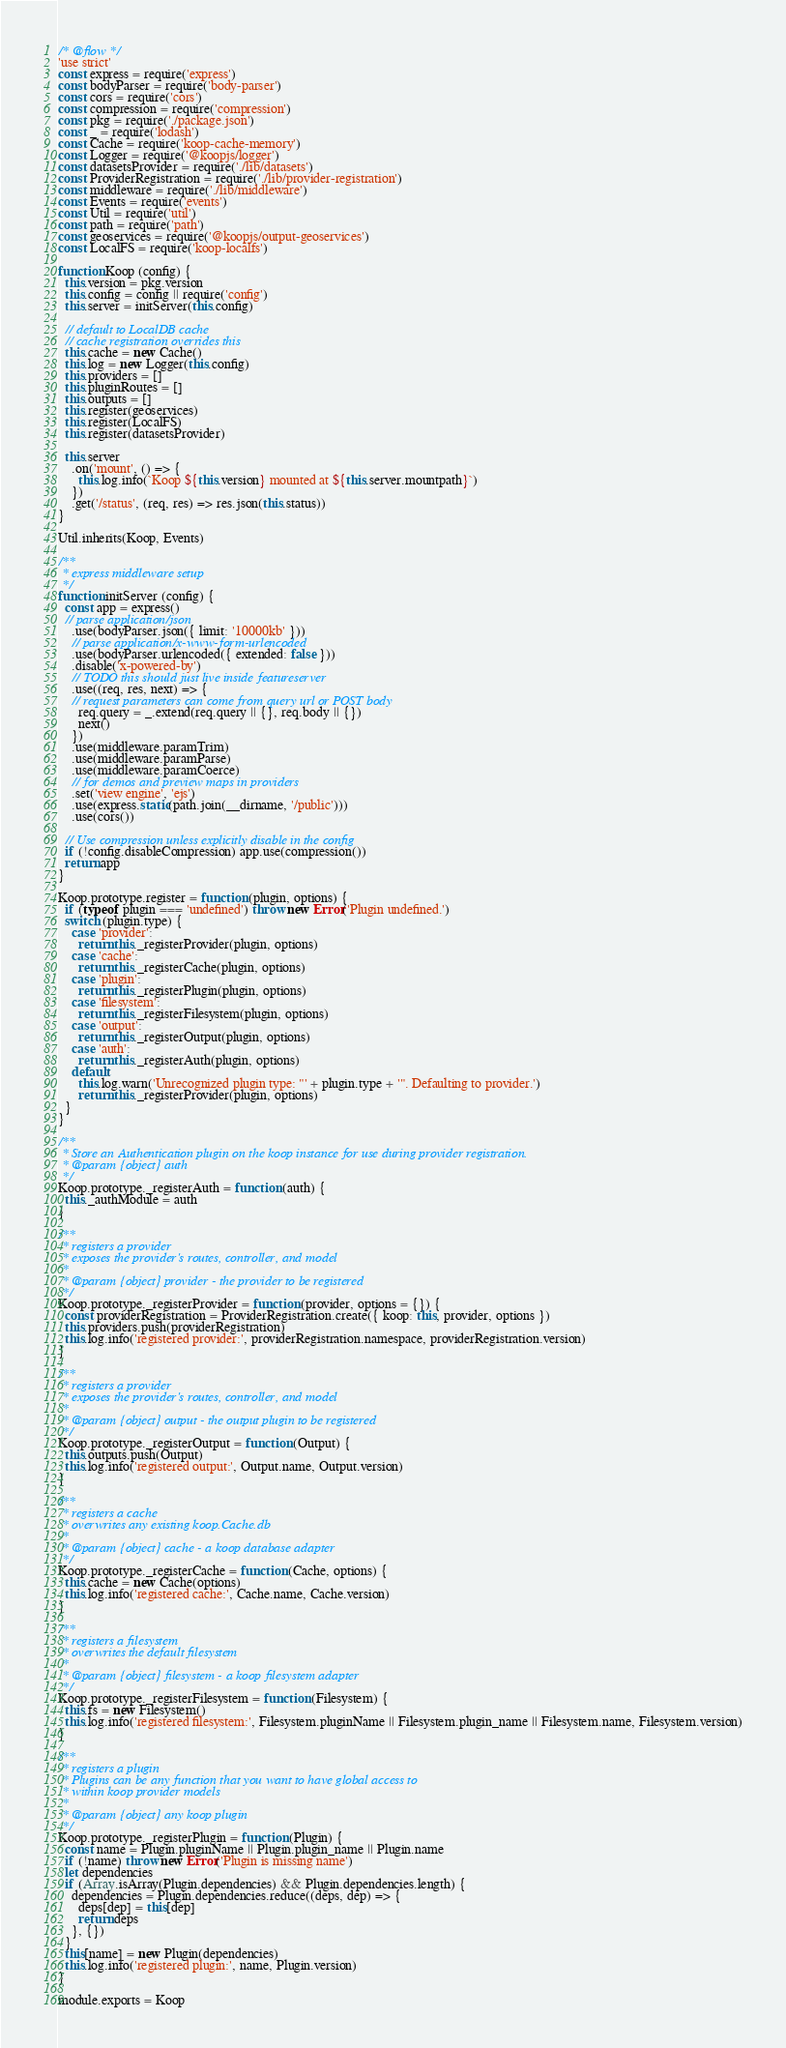Convert code to text. <code><loc_0><loc_0><loc_500><loc_500><_JavaScript_>/* @flow */
'use strict'
const express = require('express')
const bodyParser = require('body-parser')
const cors = require('cors')
const compression = require('compression')
const pkg = require('./package.json')
const _ = require('lodash')
const Cache = require('koop-cache-memory')
const Logger = require('@koopjs/logger')
const datasetsProvider = require('./lib/datasets')
const ProviderRegistration = require('./lib/provider-registration')
const middleware = require('./lib/middleware')
const Events = require('events')
const Util = require('util')
const path = require('path')
const geoservices = require('@koopjs/output-geoservices')
const LocalFS = require('koop-localfs')

function Koop (config) {
  this.version = pkg.version
  this.config = config || require('config')
  this.server = initServer(this.config)

  // default to LocalDB cache
  // cache registration overrides this
  this.cache = new Cache()
  this.log = new Logger(this.config)
  this.providers = []
  this.pluginRoutes = []
  this.outputs = []
  this.register(geoservices)
  this.register(LocalFS)
  this.register(datasetsProvider)

  this.server
    .on('mount', () => {
      this.log.info(`Koop ${this.version} mounted at ${this.server.mountpath}`)
    })
    .get('/status', (req, res) => res.json(this.status))
}

Util.inherits(Koop, Events)

/**
 * express middleware setup
 */
function initServer (config) {
  const app = express()
  // parse application/json
    .use(bodyParser.json({ limit: '10000kb' }))
    // parse application/x-www-form-urlencoded
    .use(bodyParser.urlencoded({ extended: false }))
    .disable('x-powered-by')
    // TODO this should just live inside featureserver
    .use((req, res, next) => {
    // request parameters can come from query url or POST body
      req.query = _.extend(req.query || {}, req.body || {})
      next()
    })
    .use(middleware.paramTrim)
    .use(middleware.paramParse)
    .use(middleware.paramCoerce)
    // for demos and preview maps in providers
    .set('view engine', 'ejs')
    .use(express.static(path.join(__dirname, '/public')))
    .use(cors())

  // Use compression unless explicitly disable in the config
  if (!config.disableCompression) app.use(compression())
  return app
}

Koop.prototype.register = function (plugin, options) {
  if (typeof plugin === 'undefined') throw new Error('Plugin undefined.')
  switch (plugin.type) {
    case 'provider':
      return this._registerProvider(plugin, options)
    case 'cache':
      return this._registerCache(plugin, options)
    case 'plugin':
      return this._registerPlugin(plugin, options)
    case 'filesystem':
      return this._registerFilesystem(plugin, options)
    case 'output':
      return this._registerOutput(plugin, options)
    case 'auth':
      return this._registerAuth(plugin, options)
    default:
      this.log.warn('Unrecognized plugin type: "' + plugin.type + '". Defaulting to provider.')
      return this._registerProvider(plugin, options)
  }
}

/**
 * Store an Authentication plugin on the koop instance for use during provider registration.
 * @param {object} auth
 */
Koop.prototype._registerAuth = function (auth) {
  this._authModule = auth
}

/**
 * registers a provider
 * exposes the provider's routes, controller, and model
 *
 * @param {object} provider - the provider to be registered
 */
Koop.prototype._registerProvider = function (provider, options = {}) {
  const providerRegistration = ProviderRegistration.create({ koop: this, provider, options })
  this.providers.push(providerRegistration)
  this.log.info('registered provider:', providerRegistration.namespace, providerRegistration.version)
}

/**
 * registers a provider
 * exposes the provider's routes, controller, and model
 *
 * @param {object} output - the output plugin to be registered
 */
Koop.prototype._registerOutput = function (Output) {
  this.outputs.push(Output)
  this.log.info('registered output:', Output.name, Output.version)
}

/**
 * registers a cache
 * overwrites any existing koop.Cache.db
 *
 * @param {object} cache - a koop database adapter
 */
Koop.prototype._registerCache = function (Cache, options) {
  this.cache = new Cache(options)
  this.log.info('registered cache:', Cache.name, Cache.version)
}

/**
 * registers a filesystem
 * overwrites the default filesystem
 *
 * @param {object} filesystem - a koop filesystem adapter
 */
Koop.prototype._registerFilesystem = function (Filesystem) {
  this.fs = new Filesystem()
  this.log.info('registered filesystem:', Filesystem.pluginName || Filesystem.plugin_name || Filesystem.name, Filesystem.version)
}

/**
 * registers a plugin
 * Plugins can be any function that you want to have global access to
 * within koop provider models
 *
 * @param {object} any koop plugin
 */
Koop.prototype._registerPlugin = function (Plugin) {
  const name = Plugin.pluginName || Plugin.plugin_name || Plugin.name
  if (!name) throw new Error('Plugin is missing name')
  let dependencies
  if (Array.isArray(Plugin.dependencies) && Plugin.dependencies.length) {
    dependencies = Plugin.dependencies.reduce((deps, dep) => {
      deps[dep] = this[dep]
      return deps
    }, {})
  }
  this[name] = new Plugin(dependencies)
  this.log.info('registered plugin:', name, Plugin.version)
}

module.exports = Koop
</code> 